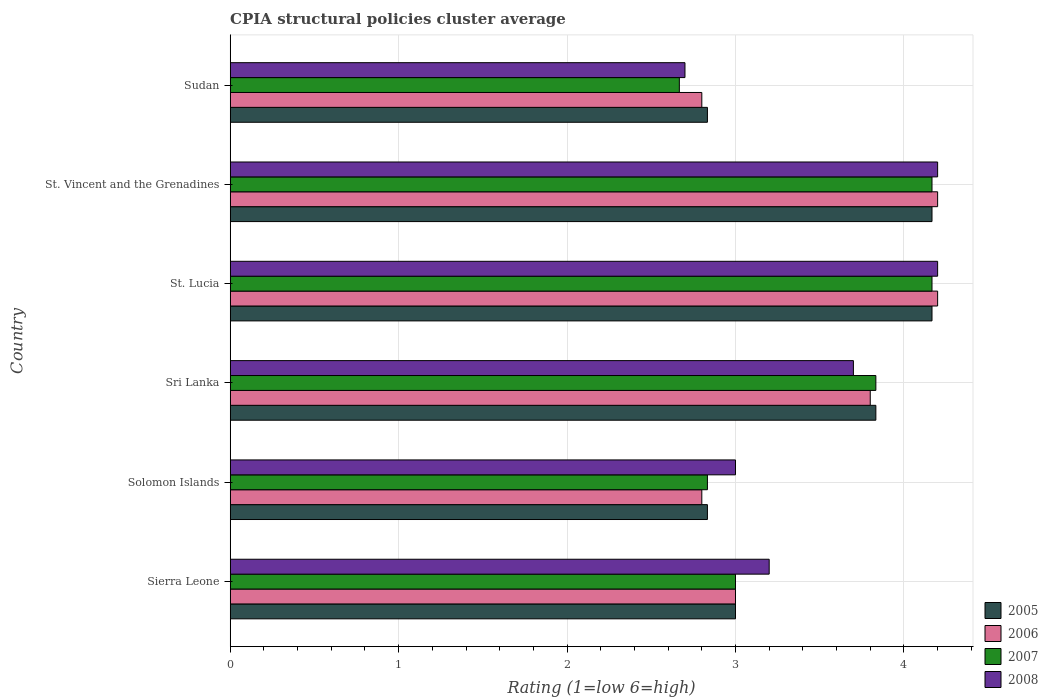How many different coloured bars are there?
Ensure brevity in your answer.  4. How many bars are there on the 5th tick from the bottom?
Offer a very short reply. 4. What is the label of the 1st group of bars from the top?
Provide a succinct answer. Sudan. What is the CPIA rating in 2005 in Sri Lanka?
Provide a short and direct response. 3.83. Across all countries, what is the maximum CPIA rating in 2008?
Your response must be concise. 4.2. Across all countries, what is the minimum CPIA rating in 2005?
Keep it short and to the point. 2.83. In which country was the CPIA rating in 2006 maximum?
Your answer should be compact. St. Lucia. In which country was the CPIA rating in 2008 minimum?
Your answer should be compact. Sudan. What is the total CPIA rating in 2007 in the graph?
Your answer should be compact. 20.67. What is the difference between the CPIA rating in 2007 in Sierra Leone and that in Solomon Islands?
Offer a very short reply. 0.17. What is the difference between the CPIA rating in 2006 in St. Lucia and the CPIA rating in 2005 in St. Vincent and the Grenadines?
Your answer should be very brief. 0.03. What is the average CPIA rating in 2007 per country?
Your answer should be compact. 3.44. What is the difference between the CPIA rating in 2007 and CPIA rating in 2005 in Sri Lanka?
Your answer should be very brief. 0. In how many countries, is the CPIA rating in 2008 greater than 0.2 ?
Your response must be concise. 6. Is the CPIA rating in 2008 in Solomon Islands less than that in St. Vincent and the Grenadines?
Make the answer very short. Yes. What is the difference between the highest and the second highest CPIA rating in 2006?
Ensure brevity in your answer.  0. What is the difference between the highest and the lowest CPIA rating in 2006?
Provide a short and direct response. 1.4. In how many countries, is the CPIA rating in 2006 greater than the average CPIA rating in 2006 taken over all countries?
Give a very brief answer. 3. Is the sum of the CPIA rating in 2006 in Sierra Leone and Sri Lanka greater than the maximum CPIA rating in 2008 across all countries?
Ensure brevity in your answer.  Yes. Is it the case that in every country, the sum of the CPIA rating in 2005 and CPIA rating in 2008 is greater than the sum of CPIA rating in 2006 and CPIA rating in 2007?
Keep it short and to the point. No. Is it the case that in every country, the sum of the CPIA rating in 2005 and CPIA rating in 2008 is greater than the CPIA rating in 2007?
Your answer should be compact. Yes. How many countries are there in the graph?
Give a very brief answer. 6. Are the values on the major ticks of X-axis written in scientific E-notation?
Make the answer very short. No. Does the graph contain any zero values?
Give a very brief answer. No. What is the title of the graph?
Offer a very short reply. CPIA structural policies cluster average. What is the Rating (1=low 6=high) of 2005 in Sierra Leone?
Your answer should be compact. 3. What is the Rating (1=low 6=high) of 2006 in Sierra Leone?
Keep it short and to the point. 3. What is the Rating (1=low 6=high) in 2007 in Sierra Leone?
Offer a very short reply. 3. What is the Rating (1=low 6=high) of 2005 in Solomon Islands?
Make the answer very short. 2.83. What is the Rating (1=low 6=high) of 2006 in Solomon Islands?
Offer a very short reply. 2.8. What is the Rating (1=low 6=high) in 2007 in Solomon Islands?
Your answer should be very brief. 2.83. What is the Rating (1=low 6=high) in 2005 in Sri Lanka?
Keep it short and to the point. 3.83. What is the Rating (1=low 6=high) of 2006 in Sri Lanka?
Offer a terse response. 3.8. What is the Rating (1=low 6=high) of 2007 in Sri Lanka?
Provide a succinct answer. 3.83. What is the Rating (1=low 6=high) of 2008 in Sri Lanka?
Provide a succinct answer. 3.7. What is the Rating (1=low 6=high) of 2005 in St. Lucia?
Offer a terse response. 4.17. What is the Rating (1=low 6=high) in 2006 in St. Lucia?
Provide a succinct answer. 4.2. What is the Rating (1=low 6=high) in 2007 in St. Lucia?
Your answer should be compact. 4.17. What is the Rating (1=low 6=high) in 2005 in St. Vincent and the Grenadines?
Your answer should be compact. 4.17. What is the Rating (1=low 6=high) of 2006 in St. Vincent and the Grenadines?
Give a very brief answer. 4.2. What is the Rating (1=low 6=high) in 2007 in St. Vincent and the Grenadines?
Offer a terse response. 4.17. What is the Rating (1=low 6=high) in 2005 in Sudan?
Offer a very short reply. 2.83. What is the Rating (1=low 6=high) of 2007 in Sudan?
Your answer should be very brief. 2.67. What is the Rating (1=low 6=high) in 2008 in Sudan?
Offer a terse response. 2.7. Across all countries, what is the maximum Rating (1=low 6=high) of 2005?
Your answer should be compact. 4.17. Across all countries, what is the maximum Rating (1=low 6=high) of 2006?
Keep it short and to the point. 4.2. Across all countries, what is the maximum Rating (1=low 6=high) of 2007?
Provide a short and direct response. 4.17. Across all countries, what is the minimum Rating (1=low 6=high) of 2005?
Provide a short and direct response. 2.83. Across all countries, what is the minimum Rating (1=low 6=high) in 2007?
Ensure brevity in your answer.  2.67. What is the total Rating (1=low 6=high) of 2005 in the graph?
Give a very brief answer. 20.83. What is the total Rating (1=low 6=high) of 2006 in the graph?
Offer a very short reply. 20.8. What is the total Rating (1=low 6=high) in 2007 in the graph?
Provide a succinct answer. 20.67. What is the total Rating (1=low 6=high) of 2008 in the graph?
Provide a short and direct response. 21. What is the difference between the Rating (1=low 6=high) in 2006 in Sierra Leone and that in Solomon Islands?
Provide a short and direct response. 0.2. What is the difference between the Rating (1=low 6=high) of 2007 in Sierra Leone and that in Solomon Islands?
Ensure brevity in your answer.  0.17. What is the difference between the Rating (1=low 6=high) of 2008 in Sierra Leone and that in Solomon Islands?
Offer a very short reply. 0.2. What is the difference between the Rating (1=low 6=high) in 2005 in Sierra Leone and that in Sri Lanka?
Ensure brevity in your answer.  -0.83. What is the difference between the Rating (1=low 6=high) of 2005 in Sierra Leone and that in St. Lucia?
Provide a succinct answer. -1.17. What is the difference between the Rating (1=low 6=high) of 2006 in Sierra Leone and that in St. Lucia?
Offer a very short reply. -1.2. What is the difference between the Rating (1=low 6=high) in 2007 in Sierra Leone and that in St. Lucia?
Provide a short and direct response. -1.17. What is the difference between the Rating (1=low 6=high) in 2008 in Sierra Leone and that in St. Lucia?
Keep it short and to the point. -1. What is the difference between the Rating (1=low 6=high) in 2005 in Sierra Leone and that in St. Vincent and the Grenadines?
Your response must be concise. -1.17. What is the difference between the Rating (1=low 6=high) of 2007 in Sierra Leone and that in St. Vincent and the Grenadines?
Provide a short and direct response. -1.17. What is the difference between the Rating (1=low 6=high) in 2008 in Sierra Leone and that in St. Vincent and the Grenadines?
Give a very brief answer. -1. What is the difference between the Rating (1=low 6=high) in 2007 in Sierra Leone and that in Sudan?
Your response must be concise. 0.33. What is the difference between the Rating (1=low 6=high) in 2008 in Sierra Leone and that in Sudan?
Ensure brevity in your answer.  0.5. What is the difference between the Rating (1=low 6=high) in 2007 in Solomon Islands and that in Sri Lanka?
Make the answer very short. -1. What is the difference between the Rating (1=low 6=high) of 2008 in Solomon Islands and that in Sri Lanka?
Your answer should be very brief. -0.7. What is the difference between the Rating (1=low 6=high) in 2005 in Solomon Islands and that in St. Lucia?
Ensure brevity in your answer.  -1.33. What is the difference between the Rating (1=low 6=high) in 2007 in Solomon Islands and that in St. Lucia?
Make the answer very short. -1.33. What is the difference between the Rating (1=low 6=high) in 2005 in Solomon Islands and that in St. Vincent and the Grenadines?
Give a very brief answer. -1.33. What is the difference between the Rating (1=low 6=high) of 2006 in Solomon Islands and that in St. Vincent and the Grenadines?
Offer a terse response. -1.4. What is the difference between the Rating (1=low 6=high) in 2007 in Solomon Islands and that in St. Vincent and the Grenadines?
Offer a terse response. -1.33. What is the difference between the Rating (1=low 6=high) in 2005 in Solomon Islands and that in Sudan?
Provide a short and direct response. 0. What is the difference between the Rating (1=low 6=high) of 2005 in Sri Lanka and that in St. Lucia?
Ensure brevity in your answer.  -0.33. What is the difference between the Rating (1=low 6=high) of 2007 in Sri Lanka and that in St. Lucia?
Ensure brevity in your answer.  -0.33. What is the difference between the Rating (1=low 6=high) of 2008 in Sri Lanka and that in St. Lucia?
Keep it short and to the point. -0.5. What is the difference between the Rating (1=low 6=high) of 2006 in Sri Lanka and that in Sudan?
Offer a terse response. 1. What is the difference between the Rating (1=low 6=high) in 2008 in Sri Lanka and that in Sudan?
Your response must be concise. 1. What is the difference between the Rating (1=low 6=high) in 2006 in St. Lucia and that in Sudan?
Ensure brevity in your answer.  1.4. What is the difference between the Rating (1=low 6=high) in 2007 in St. Lucia and that in Sudan?
Give a very brief answer. 1.5. What is the difference between the Rating (1=low 6=high) in 2005 in St. Vincent and the Grenadines and that in Sudan?
Keep it short and to the point. 1.33. What is the difference between the Rating (1=low 6=high) in 2008 in St. Vincent and the Grenadines and that in Sudan?
Keep it short and to the point. 1.5. What is the difference between the Rating (1=low 6=high) in 2005 in Sierra Leone and the Rating (1=low 6=high) in 2006 in Solomon Islands?
Offer a terse response. 0.2. What is the difference between the Rating (1=low 6=high) in 2005 in Sierra Leone and the Rating (1=low 6=high) in 2007 in Solomon Islands?
Make the answer very short. 0.17. What is the difference between the Rating (1=low 6=high) of 2006 in Sierra Leone and the Rating (1=low 6=high) of 2007 in Solomon Islands?
Offer a terse response. 0.17. What is the difference between the Rating (1=low 6=high) of 2006 in Sierra Leone and the Rating (1=low 6=high) of 2008 in Solomon Islands?
Give a very brief answer. 0. What is the difference between the Rating (1=low 6=high) of 2007 in Sierra Leone and the Rating (1=low 6=high) of 2008 in Solomon Islands?
Make the answer very short. 0. What is the difference between the Rating (1=low 6=high) in 2005 in Sierra Leone and the Rating (1=low 6=high) in 2006 in Sri Lanka?
Ensure brevity in your answer.  -0.8. What is the difference between the Rating (1=low 6=high) of 2005 in Sierra Leone and the Rating (1=low 6=high) of 2006 in St. Lucia?
Provide a short and direct response. -1.2. What is the difference between the Rating (1=low 6=high) in 2005 in Sierra Leone and the Rating (1=low 6=high) in 2007 in St. Lucia?
Make the answer very short. -1.17. What is the difference between the Rating (1=low 6=high) of 2006 in Sierra Leone and the Rating (1=low 6=high) of 2007 in St. Lucia?
Offer a very short reply. -1.17. What is the difference between the Rating (1=low 6=high) in 2005 in Sierra Leone and the Rating (1=low 6=high) in 2007 in St. Vincent and the Grenadines?
Offer a very short reply. -1.17. What is the difference between the Rating (1=low 6=high) in 2005 in Sierra Leone and the Rating (1=low 6=high) in 2008 in St. Vincent and the Grenadines?
Ensure brevity in your answer.  -1.2. What is the difference between the Rating (1=low 6=high) in 2006 in Sierra Leone and the Rating (1=low 6=high) in 2007 in St. Vincent and the Grenadines?
Offer a very short reply. -1.17. What is the difference between the Rating (1=low 6=high) in 2006 in Sierra Leone and the Rating (1=low 6=high) in 2008 in St. Vincent and the Grenadines?
Your answer should be very brief. -1.2. What is the difference between the Rating (1=low 6=high) of 2005 in Sierra Leone and the Rating (1=low 6=high) of 2007 in Sudan?
Ensure brevity in your answer.  0.33. What is the difference between the Rating (1=low 6=high) of 2005 in Sierra Leone and the Rating (1=low 6=high) of 2008 in Sudan?
Make the answer very short. 0.3. What is the difference between the Rating (1=low 6=high) in 2007 in Sierra Leone and the Rating (1=low 6=high) in 2008 in Sudan?
Give a very brief answer. 0.3. What is the difference between the Rating (1=low 6=high) of 2005 in Solomon Islands and the Rating (1=low 6=high) of 2006 in Sri Lanka?
Keep it short and to the point. -0.97. What is the difference between the Rating (1=low 6=high) in 2005 in Solomon Islands and the Rating (1=low 6=high) in 2008 in Sri Lanka?
Give a very brief answer. -0.87. What is the difference between the Rating (1=low 6=high) of 2006 in Solomon Islands and the Rating (1=low 6=high) of 2007 in Sri Lanka?
Your answer should be very brief. -1.03. What is the difference between the Rating (1=low 6=high) in 2006 in Solomon Islands and the Rating (1=low 6=high) in 2008 in Sri Lanka?
Offer a terse response. -0.9. What is the difference between the Rating (1=low 6=high) of 2007 in Solomon Islands and the Rating (1=low 6=high) of 2008 in Sri Lanka?
Offer a terse response. -0.87. What is the difference between the Rating (1=low 6=high) of 2005 in Solomon Islands and the Rating (1=low 6=high) of 2006 in St. Lucia?
Provide a short and direct response. -1.37. What is the difference between the Rating (1=low 6=high) of 2005 in Solomon Islands and the Rating (1=low 6=high) of 2007 in St. Lucia?
Offer a very short reply. -1.33. What is the difference between the Rating (1=low 6=high) of 2005 in Solomon Islands and the Rating (1=low 6=high) of 2008 in St. Lucia?
Give a very brief answer. -1.37. What is the difference between the Rating (1=low 6=high) of 2006 in Solomon Islands and the Rating (1=low 6=high) of 2007 in St. Lucia?
Your response must be concise. -1.37. What is the difference between the Rating (1=low 6=high) of 2006 in Solomon Islands and the Rating (1=low 6=high) of 2008 in St. Lucia?
Ensure brevity in your answer.  -1.4. What is the difference between the Rating (1=low 6=high) in 2007 in Solomon Islands and the Rating (1=low 6=high) in 2008 in St. Lucia?
Provide a short and direct response. -1.37. What is the difference between the Rating (1=low 6=high) of 2005 in Solomon Islands and the Rating (1=low 6=high) of 2006 in St. Vincent and the Grenadines?
Keep it short and to the point. -1.37. What is the difference between the Rating (1=low 6=high) in 2005 in Solomon Islands and the Rating (1=low 6=high) in 2007 in St. Vincent and the Grenadines?
Provide a short and direct response. -1.33. What is the difference between the Rating (1=low 6=high) in 2005 in Solomon Islands and the Rating (1=low 6=high) in 2008 in St. Vincent and the Grenadines?
Ensure brevity in your answer.  -1.37. What is the difference between the Rating (1=low 6=high) of 2006 in Solomon Islands and the Rating (1=low 6=high) of 2007 in St. Vincent and the Grenadines?
Offer a very short reply. -1.37. What is the difference between the Rating (1=low 6=high) in 2006 in Solomon Islands and the Rating (1=low 6=high) in 2008 in St. Vincent and the Grenadines?
Give a very brief answer. -1.4. What is the difference between the Rating (1=low 6=high) in 2007 in Solomon Islands and the Rating (1=low 6=high) in 2008 in St. Vincent and the Grenadines?
Keep it short and to the point. -1.37. What is the difference between the Rating (1=low 6=high) in 2005 in Solomon Islands and the Rating (1=low 6=high) in 2006 in Sudan?
Keep it short and to the point. 0.03. What is the difference between the Rating (1=low 6=high) of 2005 in Solomon Islands and the Rating (1=low 6=high) of 2008 in Sudan?
Make the answer very short. 0.13. What is the difference between the Rating (1=low 6=high) of 2006 in Solomon Islands and the Rating (1=low 6=high) of 2007 in Sudan?
Your answer should be compact. 0.13. What is the difference between the Rating (1=low 6=high) in 2006 in Solomon Islands and the Rating (1=low 6=high) in 2008 in Sudan?
Provide a succinct answer. 0.1. What is the difference between the Rating (1=low 6=high) in 2007 in Solomon Islands and the Rating (1=low 6=high) in 2008 in Sudan?
Your answer should be compact. 0.13. What is the difference between the Rating (1=low 6=high) in 2005 in Sri Lanka and the Rating (1=low 6=high) in 2006 in St. Lucia?
Provide a short and direct response. -0.37. What is the difference between the Rating (1=low 6=high) in 2005 in Sri Lanka and the Rating (1=low 6=high) in 2007 in St. Lucia?
Make the answer very short. -0.33. What is the difference between the Rating (1=low 6=high) in 2005 in Sri Lanka and the Rating (1=low 6=high) in 2008 in St. Lucia?
Your response must be concise. -0.37. What is the difference between the Rating (1=low 6=high) of 2006 in Sri Lanka and the Rating (1=low 6=high) of 2007 in St. Lucia?
Keep it short and to the point. -0.37. What is the difference between the Rating (1=low 6=high) of 2007 in Sri Lanka and the Rating (1=low 6=high) of 2008 in St. Lucia?
Offer a very short reply. -0.37. What is the difference between the Rating (1=low 6=high) of 2005 in Sri Lanka and the Rating (1=low 6=high) of 2006 in St. Vincent and the Grenadines?
Give a very brief answer. -0.37. What is the difference between the Rating (1=low 6=high) of 2005 in Sri Lanka and the Rating (1=low 6=high) of 2008 in St. Vincent and the Grenadines?
Provide a succinct answer. -0.37. What is the difference between the Rating (1=low 6=high) in 2006 in Sri Lanka and the Rating (1=low 6=high) in 2007 in St. Vincent and the Grenadines?
Make the answer very short. -0.37. What is the difference between the Rating (1=low 6=high) in 2006 in Sri Lanka and the Rating (1=low 6=high) in 2008 in St. Vincent and the Grenadines?
Provide a short and direct response. -0.4. What is the difference between the Rating (1=low 6=high) of 2007 in Sri Lanka and the Rating (1=low 6=high) of 2008 in St. Vincent and the Grenadines?
Give a very brief answer. -0.37. What is the difference between the Rating (1=low 6=high) of 2005 in Sri Lanka and the Rating (1=low 6=high) of 2006 in Sudan?
Your response must be concise. 1.03. What is the difference between the Rating (1=low 6=high) in 2005 in Sri Lanka and the Rating (1=low 6=high) in 2008 in Sudan?
Ensure brevity in your answer.  1.13. What is the difference between the Rating (1=low 6=high) of 2006 in Sri Lanka and the Rating (1=low 6=high) of 2007 in Sudan?
Provide a succinct answer. 1.13. What is the difference between the Rating (1=low 6=high) in 2006 in Sri Lanka and the Rating (1=low 6=high) in 2008 in Sudan?
Keep it short and to the point. 1.1. What is the difference between the Rating (1=low 6=high) of 2007 in Sri Lanka and the Rating (1=low 6=high) of 2008 in Sudan?
Your answer should be compact. 1.13. What is the difference between the Rating (1=low 6=high) in 2005 in St. Lucia and the Rating (1=low 6=high) in 2006 in St. Vincent and the Grenadines?
Provide a succinct answer. -0.03. What is the difference between the Rating (1=low 6=high) of 2005 in St. Lucia and the Rating (1=low 6=high) of 2008 in St. Vincent and the Grenadines?
Keep it short and to the point. -0.03. What is the difference between the Rating (1=low 6=high) of 2006 in St. Lucia and the Rating (1=low 6=high) of 2007 in St. Vincent and the Grenadines?
Offer a very short reply. 0.03. What is the difference between the Rating (1=low 6=high) in 2006 in St. Lucia and the Rating (1=low 6=high) in 2008 in St. Vincent and the Grenadines?
Your answer should be very brief. 0. What is the difference between the Rating (1=low 6=high) in 2007 in St. Lucia and the Rating (1=low 6=high) in 2008 in St. Vincent and the Grenadines?
Provide a succinct answer. -0.03. What is the difference between the Rating (1=low 6=high) in 2005 in St. Lucia and the Rating (1=low 6=high) in 2006 in Sudan?
Provide a short and direct response. 1.37. What is the difference between the Rating (1=low 6=high) of 2005 in St. Lucia and the Rating (1=low 6=high) of 2007 in Sudan?
Make the answer very short. 1.5. What is the difference between the Rating (1=low 6=high) of 2005 in St. Lucia and the Rating (1=low 6=high) of 2008 in Sudan?
Your answer should be very brief. 1.47. What is the difference between the Rating (1=low 6=high) in 2006 in St. Lucia and the Rating (1=low 6=high) in 2007 in Sudan?
Offer a terse response. 1.53. What is the difference between the Rating (1=low 6=high) of 2007 in St. Lucia and the Rating (1=low 6=high) of 2008 in Sudan?
Your response must be concise. 1.47. What is the difference between the Rating (1=low 6=high) in 2005 in St. Vincent and the Grenadines and the Rating (1=low 6=high) in 2006 in Sudan?
Provide a succinct answer. 1.37. What is the difference between the Rating (1=low 6=high) of 2005 in St. Vincent and the Grenadines and the Rating (1=low 6=high) of 2007 in Sudan?
Your answer should be very brief. 1.5. What is the difference between the Rating (1=low 6=high) in 2005 in St. Vincent and the Grenadines and the Rating (1=low 6=high) in 2008 in Sudan?
Make the answer very short. 1.47. What is the difference between the Rating (1=low 6=high) in 2006 in St. Vincent and the Grenadines and the Rating (1=low 6=high) in 2007 in Sudan?
Ensure brevity in your answer.  1.53. What is the difference between the Rating (1=low 6=high) of 2007 in St. Vincent and the Grenadines and the Rating (1=low 6=high) of 2008 in Sudan?
Give a very brief answer. 1.47. What is the average Rating (1=low 6=high) of 2005 per country?
Your answer should be compact. 3.47. What is the average Rating (1=low 6=high) in 2006 per country?
Ensure brevity in your answer.  3.47. What is the average Rating (1=low 6=high) of 2007 per country?
Give a very brief answer. 3.44. What is the average Rating (1=low 6=high) in 2008 per country?
Your response must be concise. 3.5. What is the difference between the Rating (1=low 6=high) in 2005 and Rating (1=low 6=high) in 2006 in Sierra Leone?
Keep it short and to the point. 0. What is the difference between the Rating (1=low 6=high) in 2005 and Rating (1=low 6=high) in 2007 in Sierra Leone?
Provide a succinct answer. 0. What is the difference between the Rating (1=low 6=high) of 2005 and Rating (1=low 6=high) of 2008 in Sierra Leone?
Your answer should be compact. -0.2. What is the difference between the Rating (1=low 6=high) in 2006 and Rating (1=low 6=high) in 2007 in Sierra Leone?
Make the answer very short. 0. What is the difference between the Rating (1=low 6=high) of 2006 and Rating (1=low 6=high) of 2008 in Sierra Leone?
Offer a terse response. -0.2. What is the difference between the Rating (1=low 6=high) in 2005 and Rating (1=low 6=high) in 2006 in Solomon Islands?
Your answer should be compact. 0.03. What is the difference between the Rating (1=low 6=high) of 2005 and Rating (1=low 6=high) of 2008 in Solomon Islands?
Provide a short and direct response. -0.17. What is the difference between the Rating (1=low 6=high) in 2006 and Rating (1=low 6=high) in 2007 in Solomon Islands?
Your answer should be very brief. -0.03. What is the difference between the Rating (1=low 6=high) in 2005 and Rating (1=low 6=high) in 2008 in Sri Lanka?
Offer a very short reply. 0.13. What is the difference between the Rating (1=low 6=high) of 2006 and Rating (1=low 6=high) of 2007 in Sri Lanka?
Ensure brevity in your answer.  -0.03. What is the difference between the Rating (1=low 6=high) of 2006 and Rating (1=low 6=high) of 2008 in Sri Lanka?
Your answer should be very brief. 0.1. What is the difference between the Rating (1=low 6=high) in 2007 and Rating (1=low 6=high) in 2008 in Sri Lanka?
Your answer should be compact. 0.13. What is the difference between the Rating (1=low 6=high) of 2005 and Rating (1=low 6=high) of 2006 in St. Lucia?
Keep it short and to the point. -0.03. What is the difference between the Rating (1=low 6=high) of 2005 and Rating (1=low 6=high) of 2008 in St. Lucia?
Offer a terse response. -0.03. What is the difference between the Rating (1=low 6=high) of 2007 and Rating (1=low 6=high) of 2008 in St. Lucia?
Your response must be concise. -0.03. What is the difference between the Rating (1=low 6=high) of 2005 and Rating (1=low 6=high) of 2006 in St. Vincent and the Grenadines?
Offer a very short reply. -0.03. What is the difference between the Rating (1=low 6=high) in 2005 and Rating (1=low 6=high) in 2007 in St. Vincent and the Grenadines?
Offer a very short reply. 0. What is the difference between the Rating (1=low 6=high) of 2005 and Rating (1=low 6=high) of 2008 in St. Vincent and the Grenadines?
Offer a terse response. -0.03. What is the difference between the Rating (1=low 6=high) in 2006 and Rating (1=low 6=high) in 2007 in St. Vincent and the Grenadines?
Your answer should be very brief. 0.03. What is the difference between the Rating (1=low 6=high) of 2006 and Rating (1=low 6=high) of 2008 in St. Vincent and the Grenadines?
Your answer should be very brief. 0. What is the difference between the Rating (1=low 6=high) of 2007 and Rating (1=low 6=high) of 2008 in St. Vincent and the Grenadines?
Provide a short and direct response. -0.03. What is the difference between the Rating (1=low 6=high) of 2005 and Rating (1=low 6=high) of 2006 in Sudan?
Give a very brief answer. 0.03. What is the difference between the Rating (1=low 6=high) of 2005 and Rating (1=low 6=high) of 2007 in Sudan?
Offer a terse response. 0.17. What is the difference between the Rating (1=low 6=high) of 2005 and Rating (1=low 6=high) of 2008 in Sudan?
Give a very brief answer. 0.13. What is the difference between the Rating (1=low 6=high) of 2006 and Rating (1=low 6=high) of 2007 in Sudan?
Provide a short and direct response. 0.13. What is the difference between the Rating (1=low 6=high) of 2007 and Rating (1=low 6=high) of 2008 in Sudan?
Ensure brevity in your answer.  -0.03. What is the ratio of the Rating (1=low 6=high) of 2005 in Sierra Leone to that in Solomon Islands?
Your answer should be compact. 1.06. What is the ratio of the Rating (1=low 6=high) of 2006 in Sierra Leone to that in Solomon Islands?
Provide a succinct answer. 1.07. What is the ratio of the Rating (1=low 6=high) in 2007 in Sierra Leone to that in Solomon Islands?
Your answer should be compact. 1.06. What is the ratio of the Rating (1=low 6=high) in 2008 in Sierra Leone to that in Solomon Islands?
Ensure brevity in your answer.  1.07. What is the ratio of the Rating (1=low 6=high) of 2005 in Sierra Leone to that in Sri Lanka?
Give a very brief answer. 0.78. What is the ratio of the Rating (1=low 6=high) in 2006 in Sierra Leone to that in Sri Lanka?
Your answer should be compact. 0.79. What is the ratio of the Rating (1=low 6=high) of 2007 in Sierra Leone to that in Sri Lanka?
Offer a terse response. 0.78. What is the ratio of the Rating (1=low 6=high) of 2008 in Sierra Leone to that in Sri Lanka?
Provide a short and direct response. 0.86. What is the ratio of the Rating (1=low 6=high) in 2005 in Sierra Leone to that in St. Lucia?
Offer a terse response. 0.72. What is the ratio of the Rating (1=low 6=high) in 2006 in Sierra Leone to that in St. Lucia?
Provide a succinct answer. 0.71. What is the ratio of the Rating (1=low 6=high) of 2007 in Sierra Leone to that in St. Lucia?
Offer a very short reply. 0.72. What is the ratio of the Rating (1=low 6=high) of 2008 in Sierra Leone to that in St. Lucia?
Provide a succinct answer. 0.76. What is the ratio of the Rating (1=low 6=high) of 2005 in Sierra Leone to that in St. Vincent and the Grenadines?
Ensure brevity in your answer.  0.72. What is the ratio of the Rating (1=low 6=high) of 2007 in Sierra Leone to that in St. Vincent and the Grenadines?
Offer a terse response. 0.72. What is the ratio of the Rating (1=low 6=high) in 2008 in Sierra Leone to that in St. Vincent and the Grenadines?
Provide a succinct answer. 0.76. What is the ratio of the Rating (1=low 6=high) of 2005 in Sierra Leone to that in Sudan?
Offer a very short reply. 1.06. What is the ratio of the Rating (1=low 6=high) of 2006 in Sierra Leone to that in Sudan?
Keep it short and to the point. 1.07. What is the ratio of the Rating (1=low 6=high) in 2008 in Sierra Leone to that in Sudan?
Your answer should be very brief. 1.19. What is the ratio of the Rating (1=low 6=high) in 2005 in Solomon Islands to that in Sri Lanka?
Give a very brief answer. 0.74. What is the ratio of the Rating (1=low 6=high) of 2006 in Solomon Islands to that in Sri Lanka?
Give a very brief answer. 0.74. What is the ratio of the Rating (1=low 6=high) of 2007 in Solomon Islands to that in Sri Lanka?
Your response must be concise. 0.74. What is the ratio of the Rating (1=low 6=high) in 2008 in Solomon Islands to that in Sri Lanka?
Your answer should be very brief. 0.81. What is the ratio of the Rating (1=low 6=high) in 2005 in Solomon Islands to that in St. Lucia?
Keep it short and to the point. 0.68. What is the ratio of the Rating (1=low 6=high) in 2006 in Solomon Islands to that in St. Lucia?
Make the answer very short. 0.67. What is the ratio of the Rating (1=low 6=high) in 2007 in Solomon Islands to that in St. Lucia?
Offer a very short reply. 0.68. What is the ratio of the Rating (1=low 6=high) in 2008 in Solomon Islands to that in St. Lucia?
Make the answer very short. 0.71. What is the ratio of the Rating (1=low 6=high) of 2005 in Solomon Islands to that in St. Vincent and the Grenadines?
Your response must be concise. 0.68. What is the ratio of the Rating (1=low 6=high) of 2006 in Solomon Islands to that in St. Vincent and the Grenadines?
Provide a succinct answer. 0.67. What is the ratio of the Rating (1=low 6=high) of 2007 in Solomon Islands to that in St. Vincent and the Grenadines?
Your answer should be compact. 0.68. What is the ratio of the Rating (1=low 6=high) of 2005 in Solomon Islands to that in Sudan?
Your answer should be compact. 1. What is the ratio of the Rating (1=low 6=high) in 2006 in Sri Lanka to that in St. Lucia?
Give a very brief answer. 0.9. What is the ratio of the Rating (1=low 6=high) of 2008 in Sri Lanka to that in St. Lucia?
Your answer should be very brief. 0.88. What is the ratio of the Rating (1=low 6=high) in 2006 in Sri Lanka to that in St. Vincent and the Grenadines?
Ensure brevity in your answer.  0.9. What is the ratio of the Rating (1=low 6=high) of 2008 in Sri Lanka to that in St. Vincent and the Grenadines?
Provide a succinct answer. 0.88. What is the ratio of the Rating (1=low 6=high) in 2005 in Sri Lanka to that in Sudan?
Give a very brief answer. 1.35. What is the ratio of the Rating (1=low 6=high) of 2006 in Sri Lanka to that in Sudan?
Provide a succinct answer. 1.36. What is the ratio of the Rating (1=low 6=high) in 2007 in Sri Lanka to that in Sudan?
Your answer should be compact. 1.44. What is the ratio of the Rating (1=low 6=high) in 2008 in Sri Lanka to that in Sudan?
Your response must be concise. 1.37. What is the ratio of the Rating (1=low 6=high) of 2006 in St. Lucia to that in St. Vincent and the Grenadines?
Keep it short and to the point. 1. What is the ratio of the Rating (1=low 6=high) in 2005 in St. Lucia to that in Sudan?
Your answer should be compact. 1.47. What is the ratio of the Rating (1=low 6=high) of 2006 in St. Lucia to that in Sudan?
Offer a terse response. 1.5. What is the ratio of the Rating (1=low 6=high) in 2007 in St. Lucia to that in Sudan?
Keep it short and to the point. 1.56. What is the ratio of the Rating (1=low 6=high) in 2008 in St. Lucia to that in Sudan?
Offer a terse response. 1.56. What is the ratio of the Rating (1=low 6=high) in 2005 in St. Vincent and the Grenadines to that in Sudan?
Make the answer very short. 1.47. What is the ratio of the Rating (1=low 6=high) of 2006 in St. Vincent and the Grenadines to that in Sudan?
Offer a very short reply. 1.5. What is the ratio of the Rating (1=low 6=high) of 2007 in St. Vincent and the Grenadines to that in Sudan?
Make the answer very short. 1.56. What is the ratio of the Rating (1=low 6=high) of 2008 in St. Vincent and the Grenadines to that in Sudan?
Offer a terse response. 1.56. What is the difference between the highest and the second highest Rating (1=low 6=high) of 2007?
Offer a very short reply. 0. What is the difference between the highest and the second highest Rating (1=low 6=high) in 2008?
Your response must be concise. 0. What is the difference between the highest and the lowest Rating (1=low 6=high) of 2005?
Keep it short and to the point. 1.33. What is the difference between the highest and the lowest Rating (1=low 6=high) of 2006?
Your answer should be very brief. 1.4. What is the difference between the highest and the lowest Rating (1=low 6=high) of 2007?
Provide a succinct answer. 1.5. 